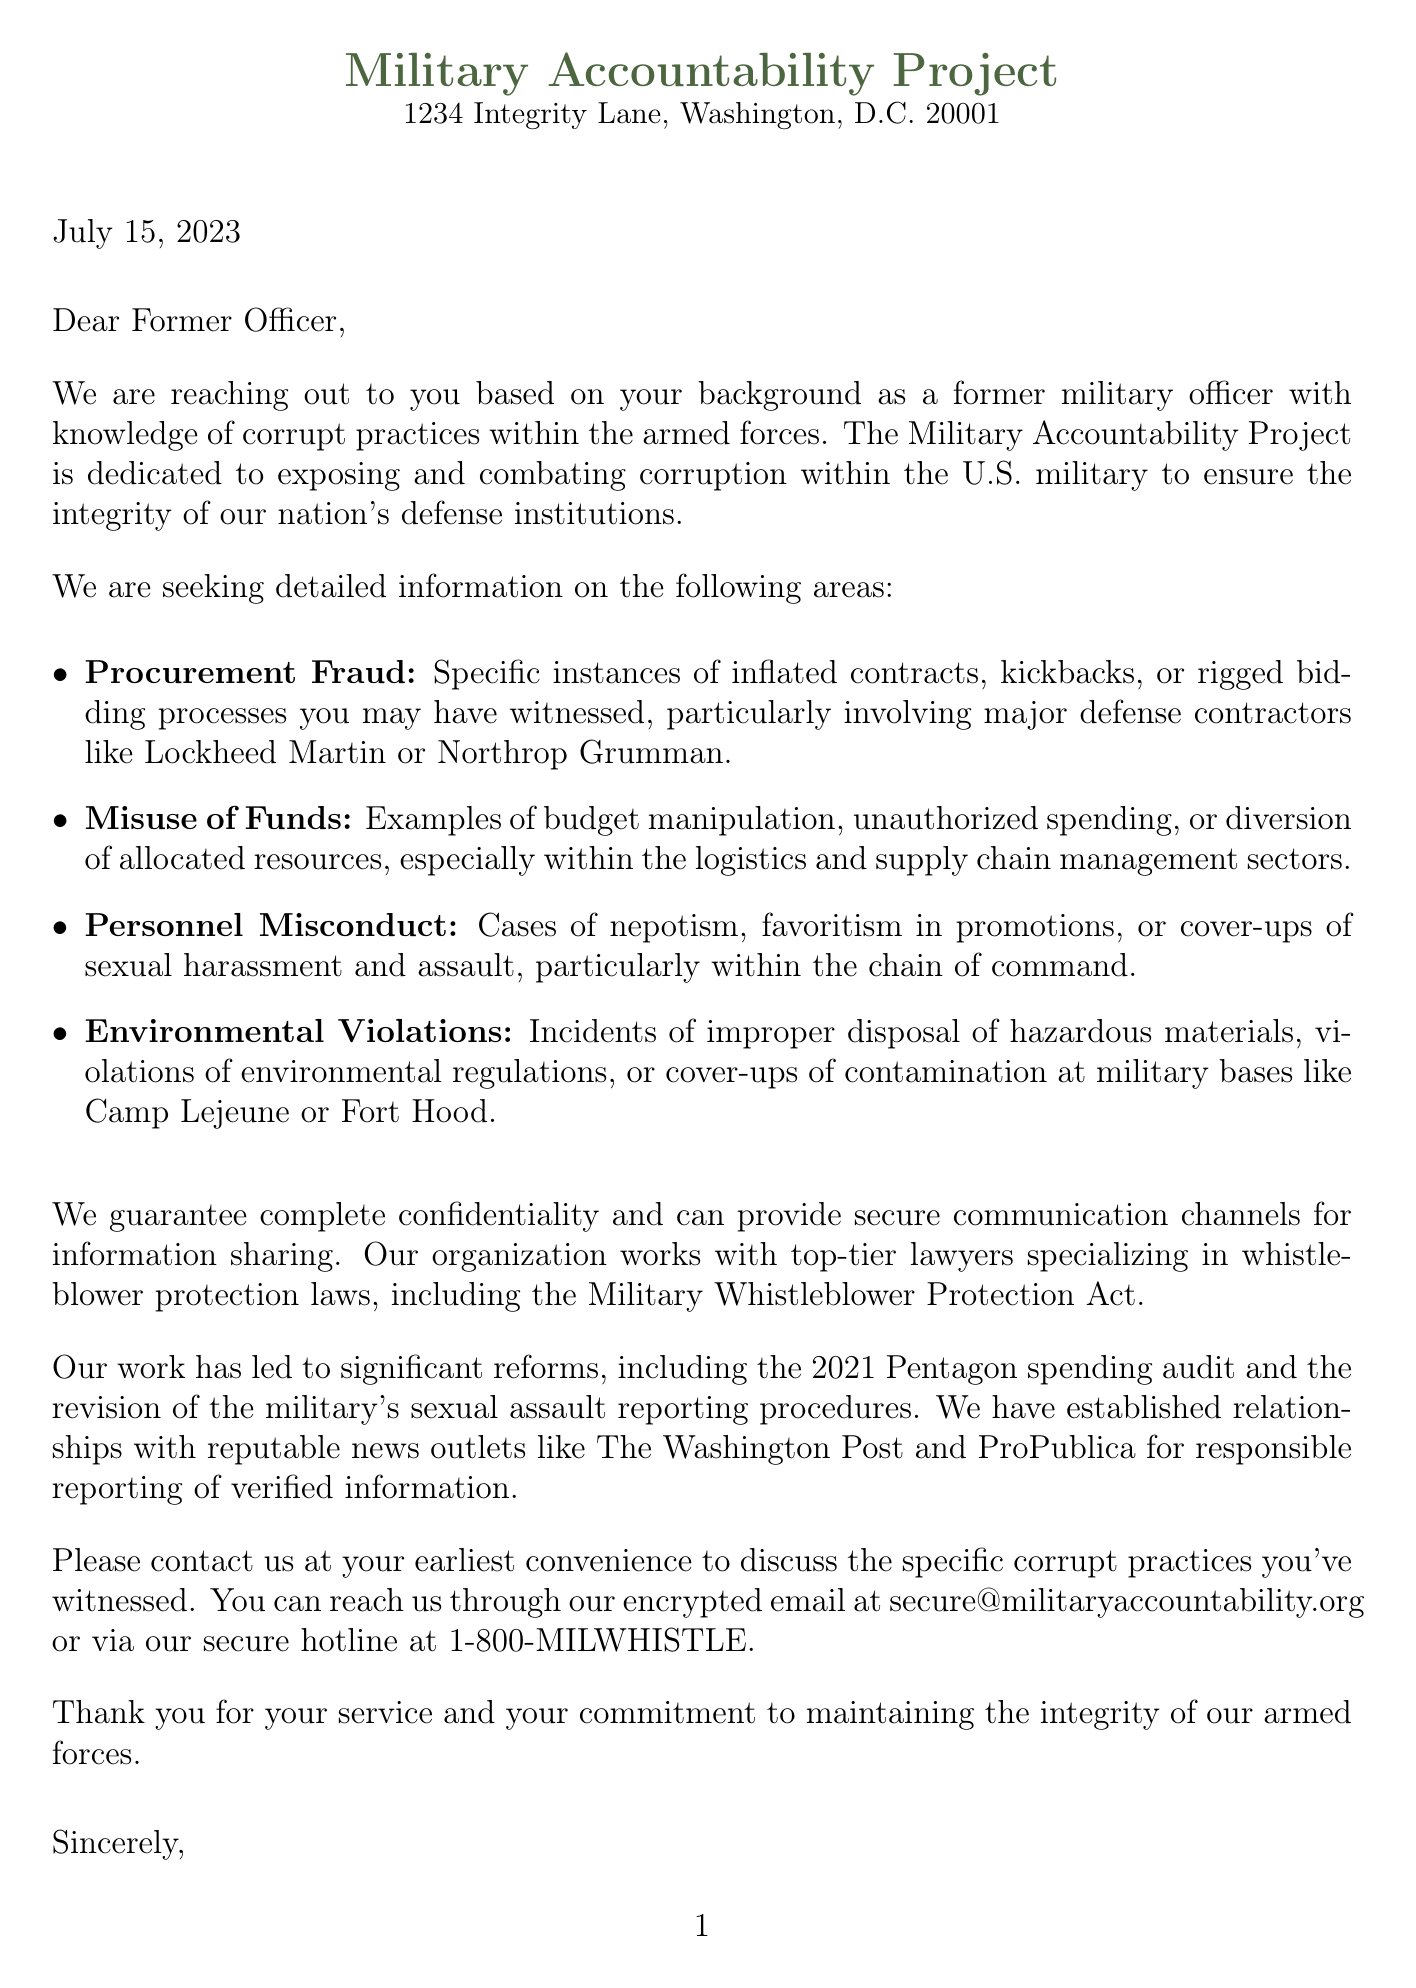What is the name of the organization sending the letter? The organization sending the letter is identified at the top of the document.
Answer: Military Accountability Project What is the address of the organization? The address is provided right below the organization name in the letter header.
Answer: 1234 Integrity Lane, Washington, D.C. 20001 What date was the letter written? The date is mentioned in the letter just after the address.
Answer: July 15, 2023 What specific misconduct category involves major defense contractors? The letter specifies misconduct related to procurement in this category.
Answer: Procurement Fraud Which act does the organization work with to ensure whistleblower protection? The specific act mentioned provides legal protection for whistleblowers in the military context.
Answer: Military Whistleblower Protection Act How many success stories are referenced in the letter? The letter cites one notable success story which is a significant reform.
Answer: 2021 Pentagon spending audit What are the contact methods provided for further information? The letter includes multiple contact methods for secure communication.
Answer: Encrypted email and secure hotline Who signed the letter? The signature at the end of the letter is from the Executive Director.
Answer: Emily Rodriguez What is the mission of the Military Accountability Project? The mission statement describes the organization's goal in combating corruption.
Answer: To expose and combat corruption within the U.S. military 